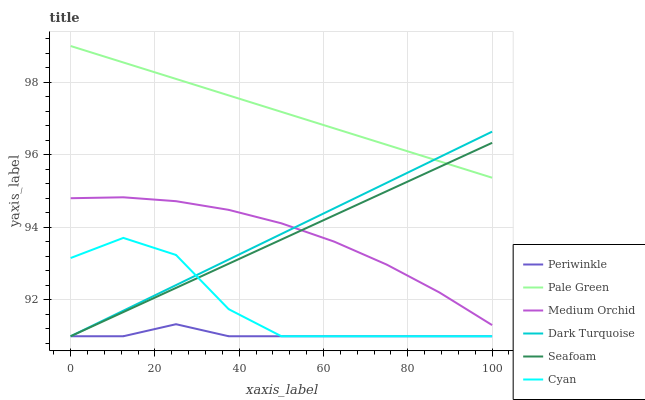Does Periwinkle have the minimum area under the curve?
Answer yes or no. Yes. Does Pale Green have the maximum area under the curve?
Answer yes or no. Yes. Does Medium Orchid have the minimum area under the curve?
Answer yes or no. No. Does Medium Orchid have the maximum area under the curve?
Answer yes or no. No. Is Pale Green the smoothest?
Answer yes or no. Yes. Is Cyan the roughest?
Answer yes or no. Yes. Is Medium Orchid the smoothest?
Answer yes or no. No. Is Medium Orchid the roughest?
Answer yes or no. No. Does Dark Turquoise have the lowest value?
Answer yes or no. Yes. Does Medium Orchid have the lowest value?
Answer yes or no. No. Does Pale Green have the highest value?
Answer yes or no. Yes. Does Medium Orchid have the highest value?
Answer yes or no. No. Is Cyan less than Pale Green?
Answer yes or no. Yes. Is Pale Green greater than Cyan?
Answer yes or no. Yes. Does Dark Turquoise intersect Periwinkle?
Answer yes or no. Yes. Is Dark Turquoise less than Periwinkle?
Answer yes or no. No. Is Dark Turquoise greater than Periwinkle?
Answer yes or no. No. Does Cyan intersect Pale Green?
Answer yes or no. No. 